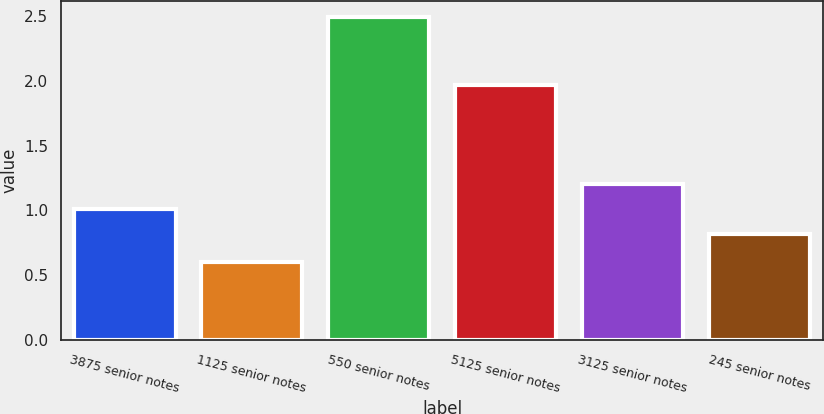Convert chart. <chart><loc_0><loc_0><loc_500><loc_500><bar_chart><fcel>3875 senior notes<fcel>1125 senior notes<fcel>550 senior notes<fcel>5125 senior notes<fcel>3125 senior notes<fcel>245 senior notes<nl><fcel>1.01<fcel>0.6<fcel>2.49<fcel>1.97<fcel>1.2<fcel>0.82<nl></chart> 